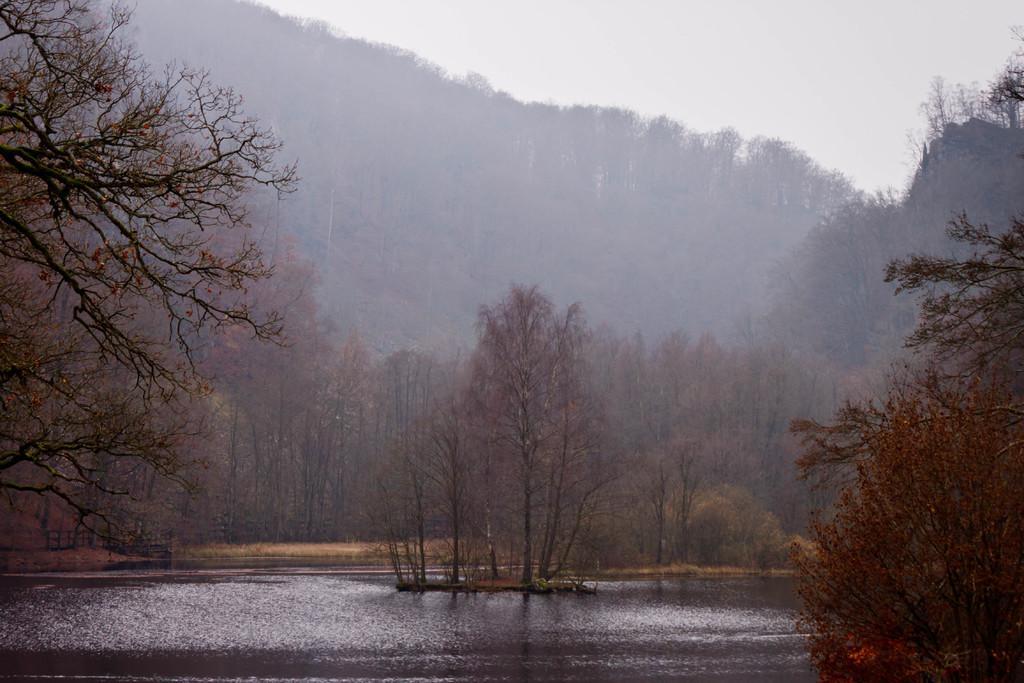Describe this image in one or two sentences. In this image we can see a group of trees. Behind the trees we can see the hills. At the top we can see the sky. At the bottom we can see the water. 